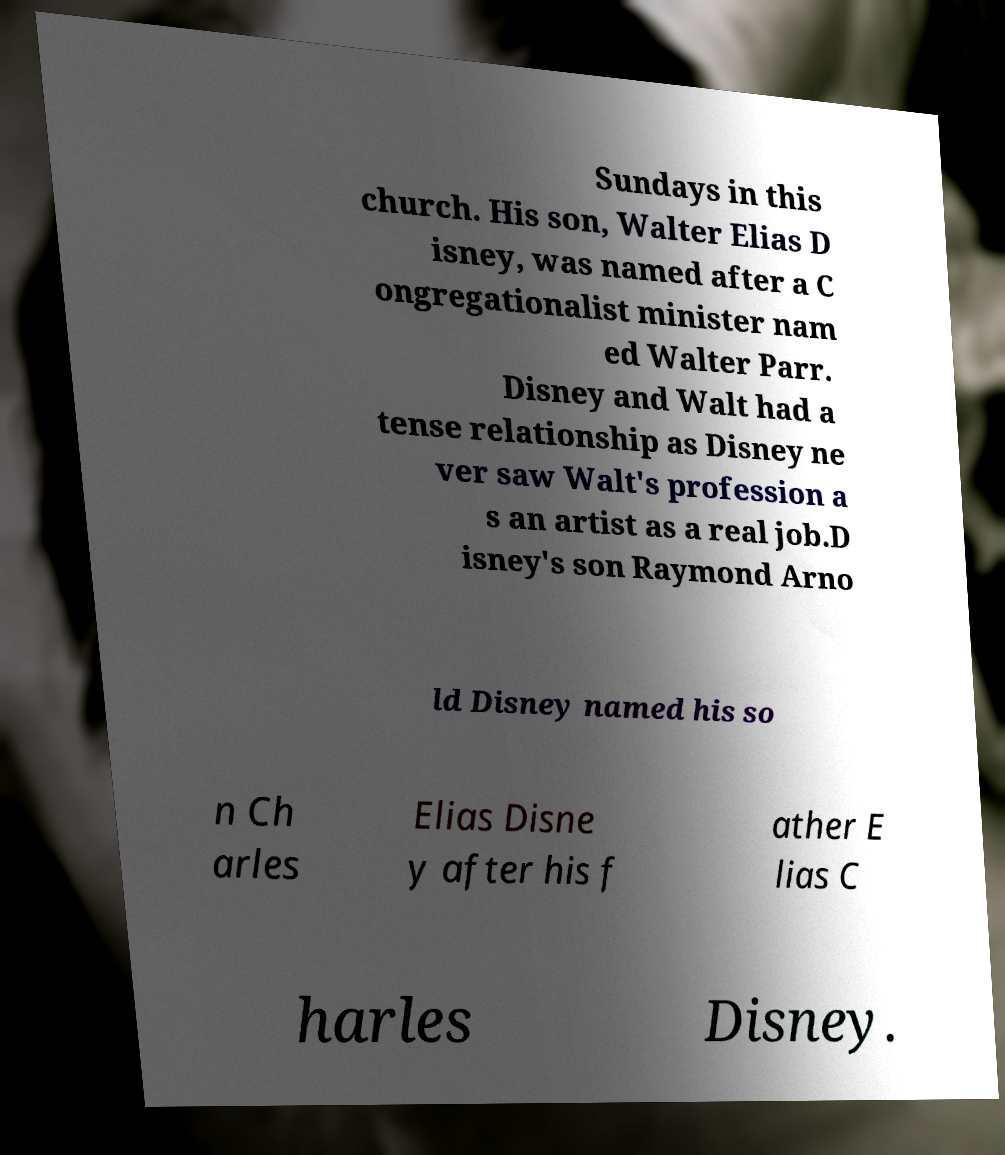Could you extract and type out the text from this image? Sundays in this church. His son, Walter Elias D isney, was named after a C ongregationalist minister nam ed Walter Parr. Disney and Walt had a tense relationship as Disney ne ver saw Walt's profession a s an artist as a real job.D isney's son Raymond Arno ld Disney named his so n Ch arles Elias Disne y after his f ather E lias C harles Disney. 